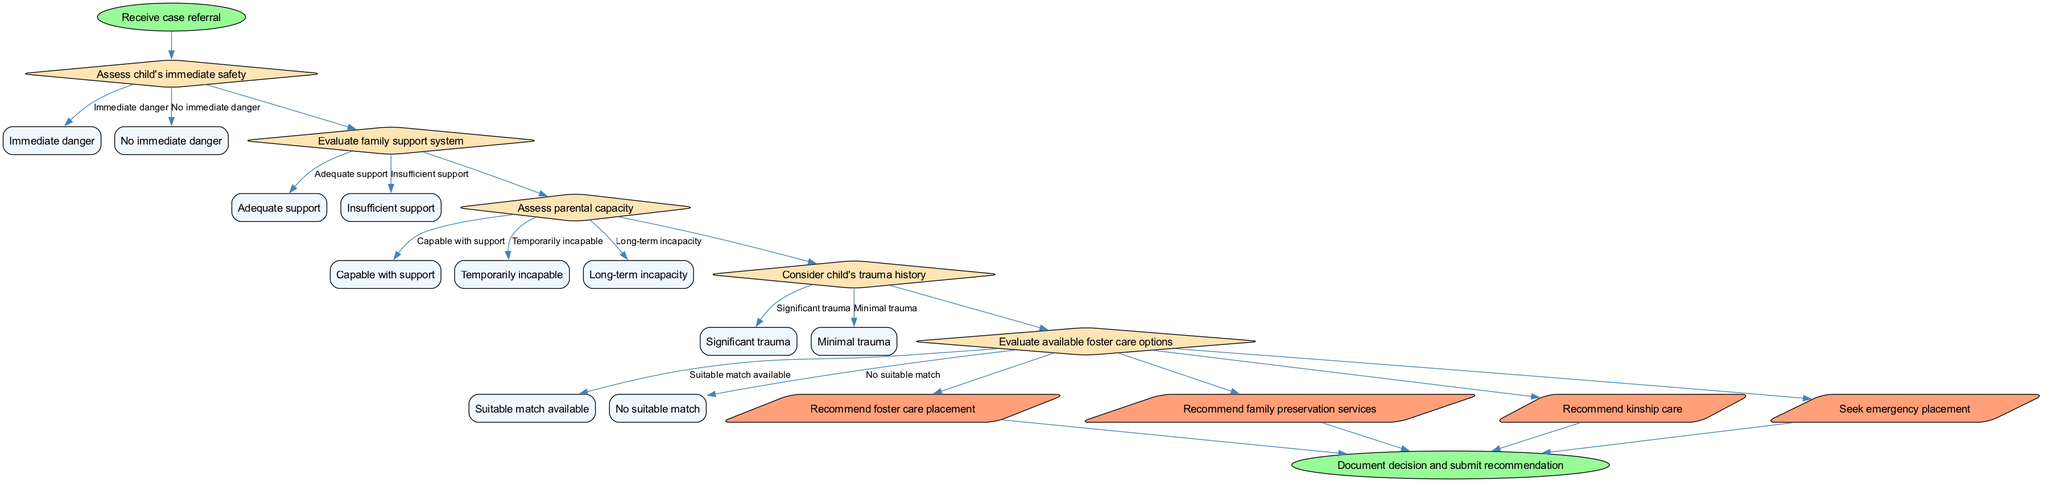What is the starting point of the decision-making process? The starting point is indicated as the first node in the flow chart, labeled "Receive case referral". This node signifies the initiation of the decision-making process.
Answer: Receive case referral How many decisions are assessed in the process? By counting the decision nodes in the diagram, there are five distinct decisions listed in the flow chart: "Assess child's immediate safety", "Evaluate family support system", "Assess parental capacity", "Consider child's trauma history", and "Evaluate available foster care options".
Answer: 5 What happens if the child is assessed as being in immediate danger? Following the decision "Assess child's immediate safety", if the option "Immediate danger" is selected, the flow suggests a more urgent response, likely leading to seeking emergency placement as an outcome.
Answer: Seek emergency placement Which decision connects directly to considering a child's trauma history? The decision that connects directly to "Consider child's trauma history" comes after "Assess parental capacity" in the flow of the diagram, indicating a sequence where parental capacity is assessed first.
Answer: Assess parental capacity What is the final step after making a recommendation? The final step in the process, indicated by the end node, is to "Document decision and submit recommendation", which concludes the decision-making flow.
Answer: Document decision and submit recommendation If a child has significant trauma and insufficient family support, what outcomes are possible? Analyzing the flow, if "Significant trauma" is identified and there is "Insufficient support", the likely outcomes could include recommending foster care placement or kinship care, depending on the availability of suitable matches.
Answer: Recommend foster care placement, recommend kinship care How are the outcomes determined in relation to the last decision made? The outcomes are determined based on the decision "Evaluate available foster care options", where if there is a "Suitable match available", it may lead to a recommendation for foster care placement. Conversely, "No suitable match" may redirect the recommendation towards other options.
Answer: Recommend foster care placement or other options What shapes are used for decision nodes in the flow chart? The decision nodes in the flow chart are represented using diamond shapes, which is standard for indicating decision points in flow chart diagrams.
Answer: Diamond How does one transition from assessing parental capacity to evaluating foster care options? The transition occurs smoothly from the decision "Assess parental capacity" to "Evaluate available foster care options", showing a direct flow in the decision-making sequence that follows prior assessments logically.
Answer: Direct transition 